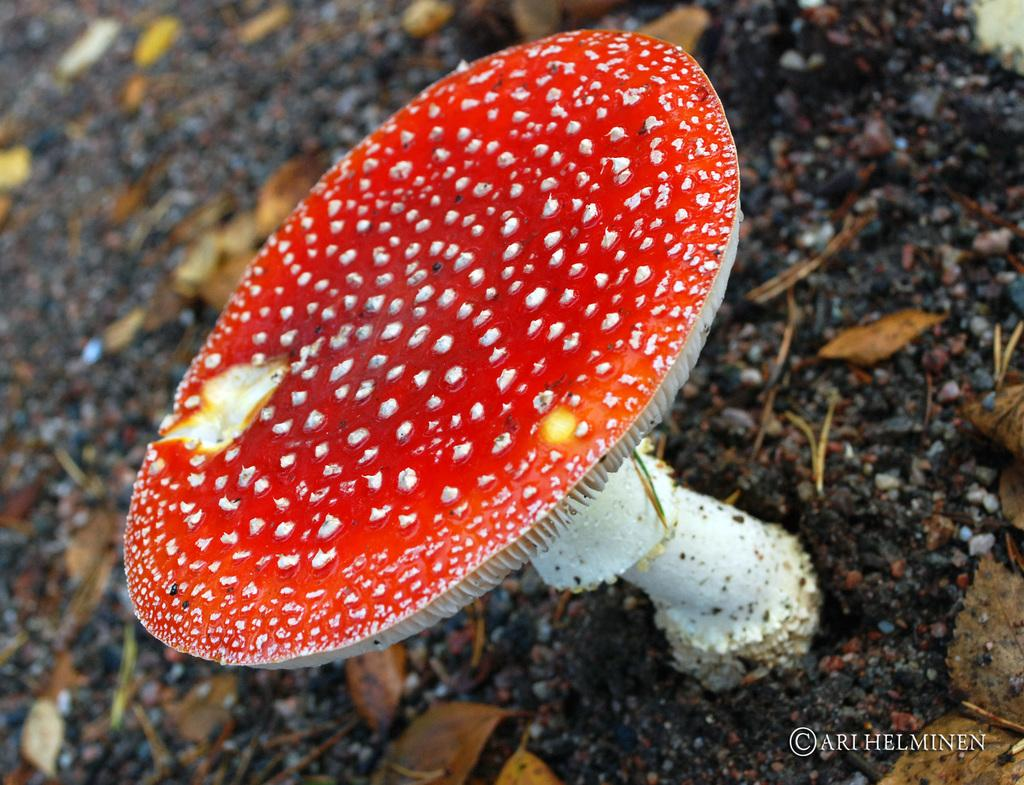What is the main subject of the image? There is a mushroom in the image. What can be seen in the background of the image? There is ground visible in the background of the image. What is present on the ground in the background of the image? Leaves are present on the ground in the background of the image. What type of glove is being used to pick up the mushroom in the image? There is no glove present in the image, and no one is picking up the mushroom. 